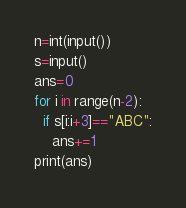Convert code to text. <code><loc_0><loc_0><loc_500><loc_500><_Python_>n=int(input())
s=input()
ans=0
for i in range(n-2):
  if s[i:i+3]=="ABC":
    ans+=1
print(ans)</code> 